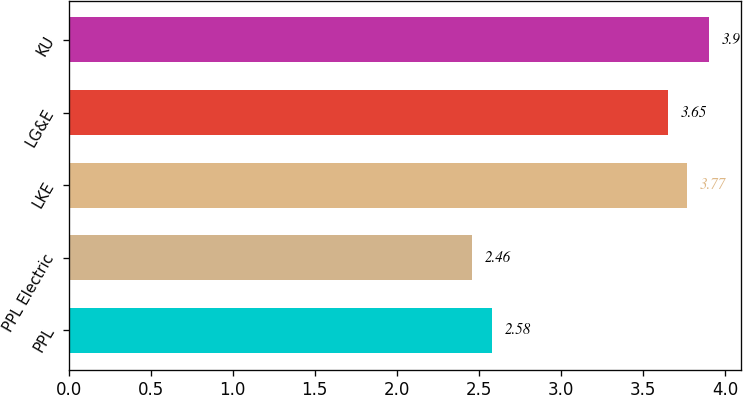Convert chart to OTSL. <chart><loc_0><loc_0><loc_500><loc_500><bar_chart><fcel>PPL<fcel>PPL Electric<fcel>LKE<fcel>LG&E<fcel>KU<nl><fcel>2.58<fcel>2.46<fcel>3.77<fcel>3.65<fcel>3.9<nl></chart> 